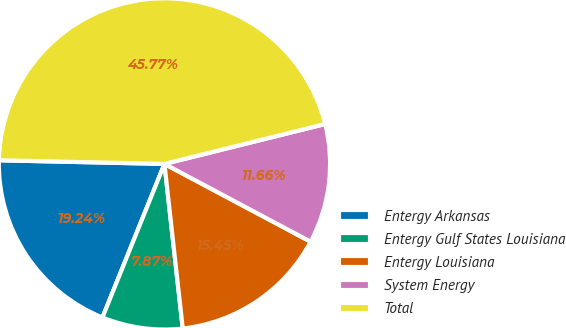Convert chart. <chart><loc_0><loc_0><loc_500><loc_500><pie_chart><fcel>Entergy Arkansas<fcel>Entergy Gulf States Louisiana<fcel>Entergy Louisiana<fcel>System Energy<fcel>Total<nl><fcel>19.24%<fcel>7.87%<fcel>15.45%<fcel>11.66%<fcel>45.77%<nl></chart> 